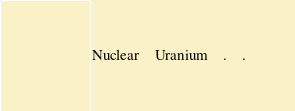<code> <loc_0><loc_0><loc_500><loc_500><_SQL_>Nuclear	Uranium	.	.
</code> 